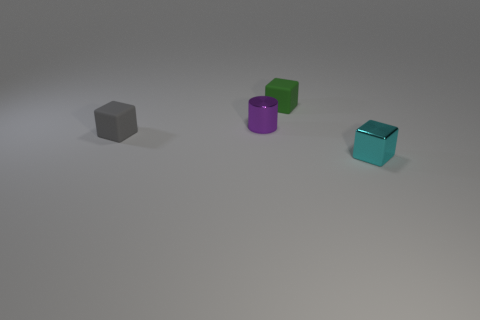Do the small gray object and the tiny object in front of the small gray object have the same material? While it's difficult to determine material composition from the image alone, the small gray object appears to have a matte finish, whereas the tiny object in front of it seems to exhibit a slightly reflective surface, suggesting that they might be made of different materials, or at least have different surface treatments. 